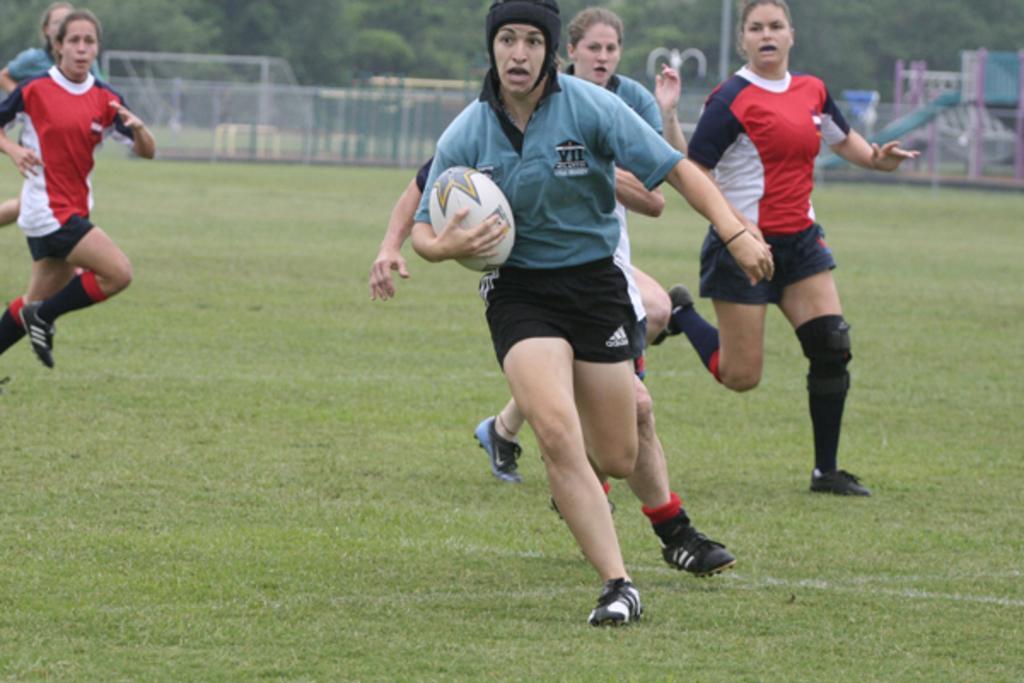Could you give a brief overview of what you see in this image? In this image we can see few people playing in the ground, a person is holding a ball and there is a fence, few objects and trees in the background. 